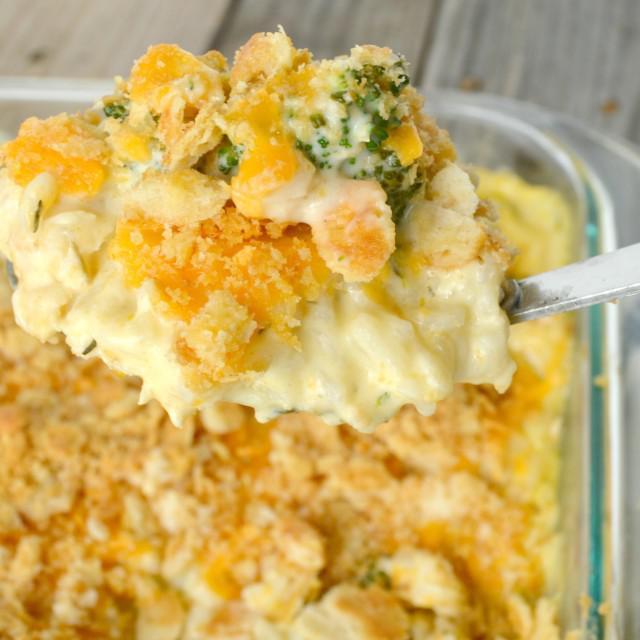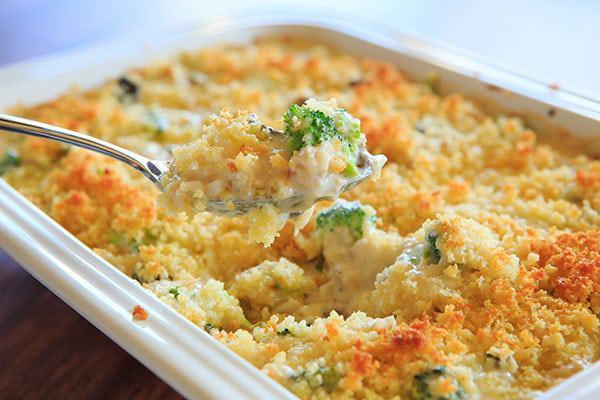The first image is the image on the left, the second image is the image on the right. Given the left and right images, does the statement "Right image shows a casserole served in a white squarish dish, with a silver serving utensil." hold true? Answer yes or no. Yes. The first image is the image on the left, the second image is the image on the right. For the images displayed, is the sentence "The casserole sits in a blue and white dish in one of the images." factually correct? Answer yes or no. No. 